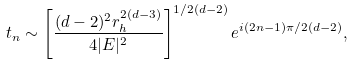Convert formula to latex. <formula><loc_0><loc_0><loc_500><loc_500>t _ { n } \sim \left [ \frac { ( d - 2 ) ^ { 2 } r _ { h } ^ { 2 ( d - 3 ) } } { 4 | E | ^ { 2 } } \right ] ^ { 1 / 2 ( d - 2 ) } e ^ { i ( 2 n - 1 ) \pi / 2 ( d - 2 ) } ,</formula> 